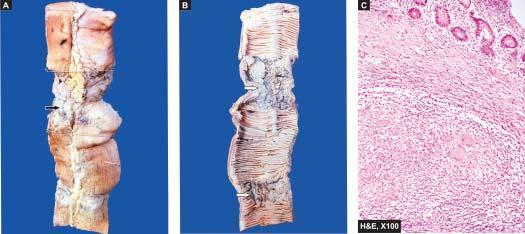what does microscopy of intestine show?
Answer the question using a single word or phrase. Caseating epithelioid cell granulomas in the intestinal wall 